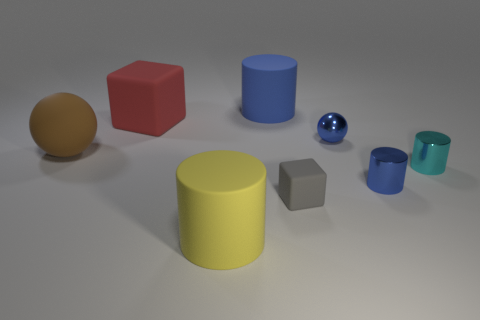Subtract all big blue rubber cylinders. How many cylinders are left? 3 Subtract all balls. How many objects are left? 6 Subtract 4 cylinders. How many cylinders are left? 0 Add 3 big red things. How many big red things exist? 4 Add 1 small blue spheres. How many objects exist? 9 Subtract all blue spheres. How many spheres are left? 1 Subtract 2 blue cylinders. How many objects are left? 6 Subtract all red blocks. Subtract all blue balls. How many blocks are left? 1 Subtract all red spheres. How many green cubes are left? 0 Subtract all cylinders. Subtract all small matte cubes. How many objects are left? 3 